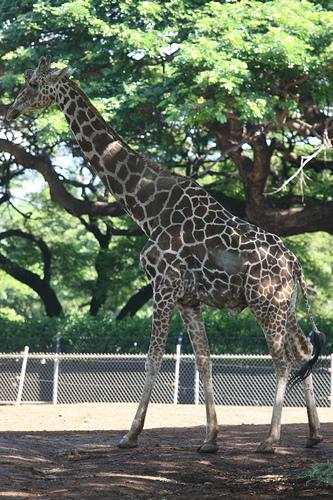Question: how many people are sitting on the giraffe?
Choices:
A. Zero.
B. One.
C. Two.
D. Three.
Answer with the letter. Answer: A Question: how many dinosaurs are in the picture?
Choices:
A. Zero.
B. One.
C. Two.
D. Three.
Answer with the letter. Answer: A Question: how many legs does the giraffe have?
Choices:
A. Two.
B. Three.
C. Four.
D. Five.
Answer with the letter. Answer: C 